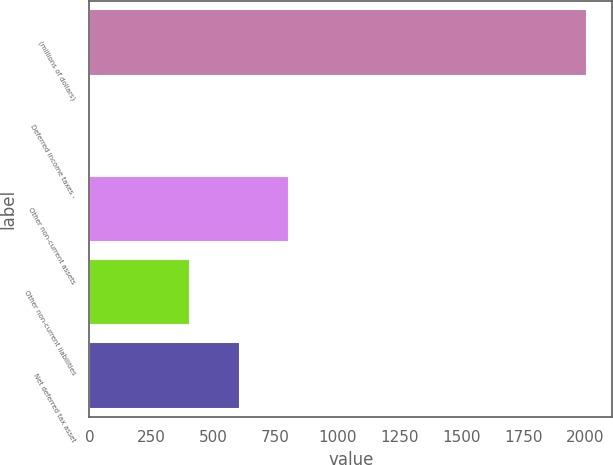Convert chart. <chart><loc_0><loc_0><loc_500><loc_500><bar_chart><fcel>(millions of dollars)<fcel>Deferred income taxes -<fcel>Other non-current assets<fcel>Other non-current liabilities<fcel>Net deferred tax asset<nl><fcel>2009<fcel>4.8<fcel>806.48<fcel>405.64<fcel>606.06<nl></chart> 